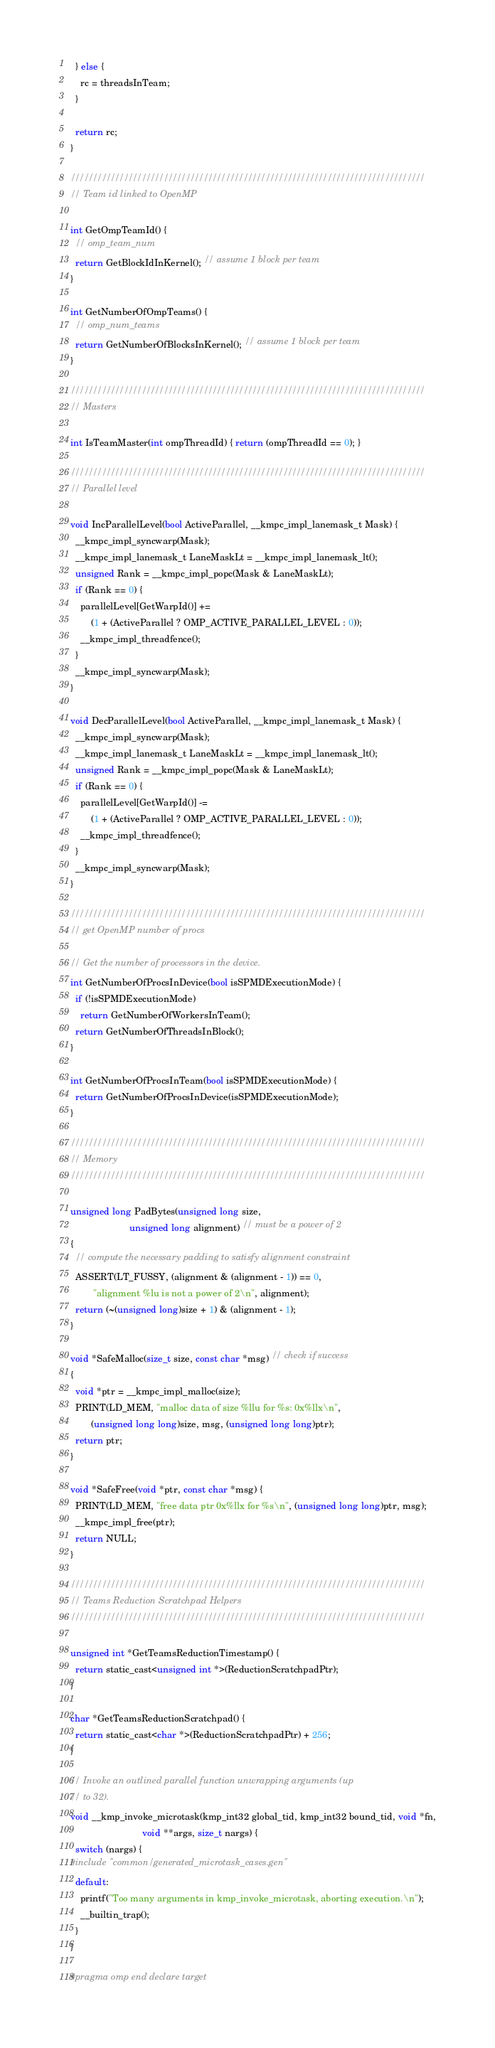Convert code to text. <code><loc_0><loc_0><loc_500><loc_500><_Cuda_>  } else {
    rc = threadsInTeam;
  }

  return rc;
}

////////////////////////////////////////////////////////////////////////////////
// Team id linked to OpenMP

int GetOmpTeamId() {
  // omp_team_num
  return GetBlockIdInKernel(); // assume 1 block per team
}

int GetNumberOfOmpTeams() {
  // omp_num_teams
  return GetNumberOfBlocksInKernel(); // assume 1 block per team
}

////////////////////////////////////////////////////////////////////////////////
// Masters

int IsTeamMaster(int ompThreadId) { return (ompThreadId == 0); }

////////////////////////////////////////////////////////////////////////////////
// Parallel level

void IncParallelLevel(bool ActiveParallel, __kmpc_impl_lanemask_t Mask) {
  __kmpc_impl_syncwarp(Mask);
  __kmpc_impl_lanemask_t LaneMaskLt = __kmpc_impl_lanemask_lt();
  unsigned Rank = __kmpc_impl_popc(Mask & LaneMaskLt);
  if (Rank == 0) {
    parallelLevel[GetWarpId()] +=
        (1 + (ActiveParallel ? OMP_ACTIVE_PARALLEL_LEVEL : 0));
    __kmpc_impl_threadfence();
  }
  __kmpc_impl_syncwarp(Mask);
}

void DecParallelLevel(bool ActiveParallel, __kmpc_impl_lanemask_t Mask) {
  __kmpc_impl_syncwarp(Mask);
  __kmpc_impl_lanemask_t LaneMaskLt = __kmpc_impl_lanemask_lt();
  unsigned Rank = __kmpc_impl_popc(Mask & LaneMaskLt);
  if (Rank == 0) {
    parallelLevel[GetWarpId()] -=
        (1 + (ActiveParallel ? OMP_ACTIVE_PARALLEL_LEVEL : 0));
    __kmpc_impl_threadfence();
  }
  __kmpc_impl_syncwarp(Mask);
}

////////////////////////////////////////////////////////////////////////////////
// get OpenMP number of procs

// Get the number of processors in the device.
int GetNumberOfProcsInDevice(bool isSPMDExecutionMode) {
  if (!isSPMDExecutionMode)
    return GetNumberOfWorkersInTeam();
  return GetNumberOfThreadsInBlock();
}

int GetNumberOfProcsInTeam(bool isSPMDExecutionMode) {
  return GetNumberOfProcsInDevice(isSPMDExecutionMode);
}

////////////////////////////////////////////////////////////////////////////////
// Memory
////////////////////////////////////////////////////////////////////////////////

unsigned long PadBytes(unsigned long size,
                       unsigned long alignment) // must be a power of 2
{
  // compute the necessary padding to satisfy alignment constraint
  ASSERT(LT_FUSSY, (alignment & (alignment - 1)) == 0,
         "alignment %lu is not a power of 2\n", alignment);
  return (~(unsigned long)size + 1) & (alignment - 1);
}

void *SafeMalloc(size_t size, const char *msg) // check if success
{
  void *ptr = __kmpc_impl_malloc(size);
  PRINT(LD_MEM, "malloc data of size %llu for %s: 0x%llx\n",
        (unsigned long long)size, msg, (unsigned long long)ptr);
  return ptr;
}

void *SafeFree(void *ptr, const char *msg) {
  PRINT(LD_MEM, "free data ptr 0x%llx for %s\n", (unsigned long long)ptr, msg);
  __kmpc_impl_free(ptr);
  return NULL;
}

////////////////////////////////////////////////////////////////////////////////
// Teams Reduction Scratchpad Helpers
////////////////////////////////////////////////////////////////////////////////

unsigned int *GetTeamsReductionTimestamp() {
  return static_cast<unsigned int *>(ReductionScratchpadPtr);
}

char *GetTeamsReductionScratchpad() {
  return static_cast<char *>(ReductionScratchpadPtr) + 256;
}

// Invoke an outlined parallel function unwrapping arguments (up
// to 32).
void __kmp_invoke_microtask(kmp_int32 global_tid, kmp_int32 bound_tid, void *fn,
                            void **args, size_t nargs) {
  switch (nargs) {
#include "common/generated_microtask_cases.gen"
  default:
    printf("Too many arguments in kmp_invoke_microtask, aborting execution.\n");
    __builtin_trap();
  }
}

#pragma omp end declare target
</code> 